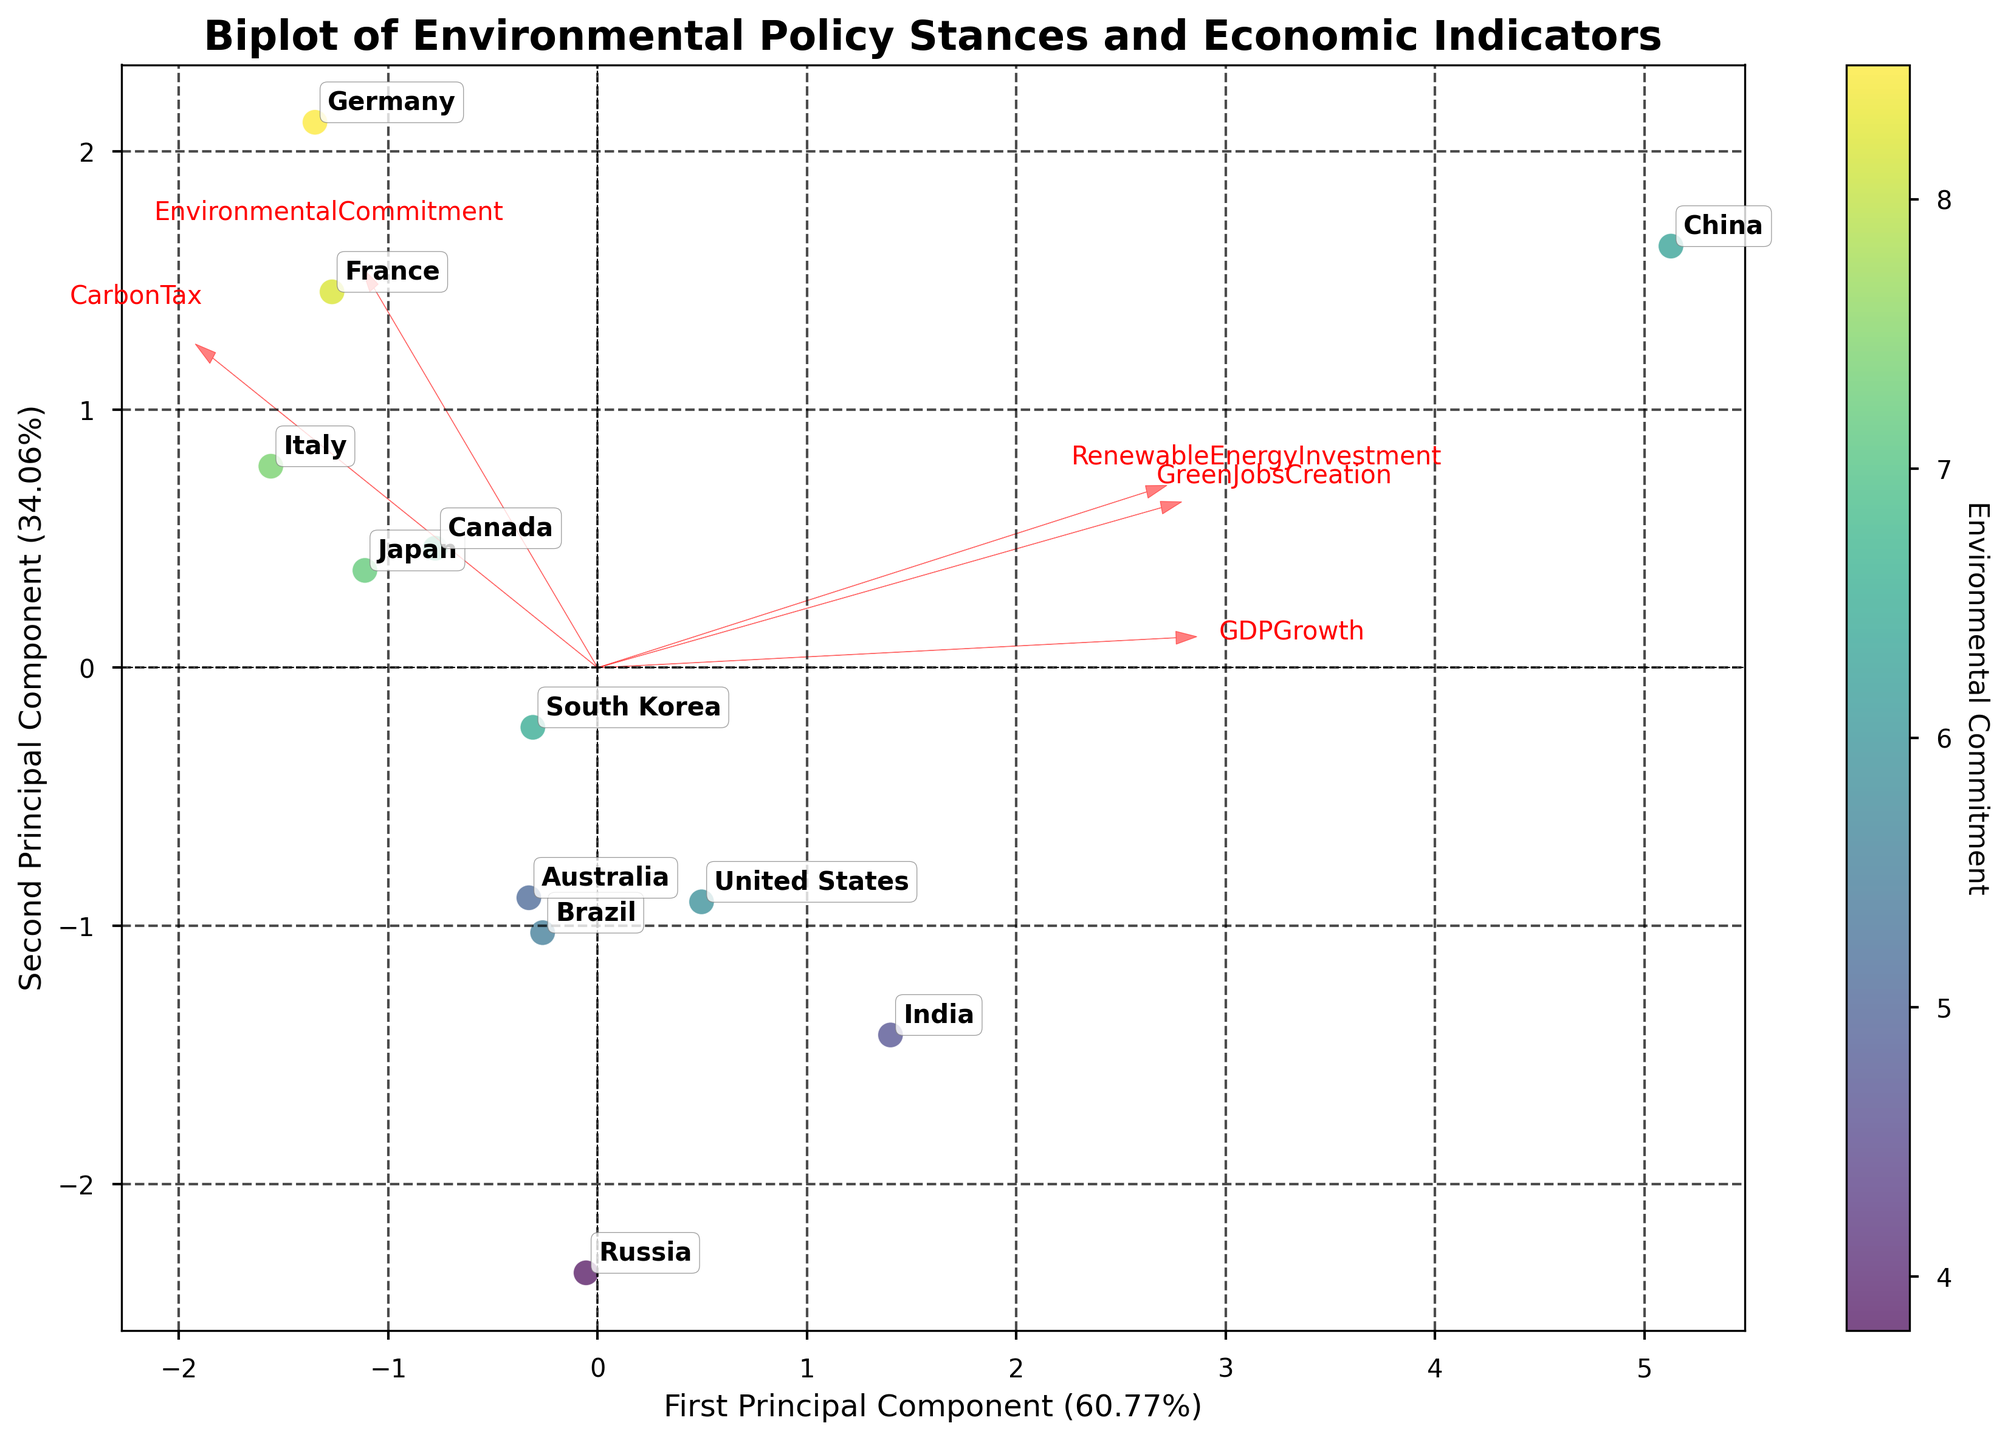What is the title of the figure? The title is typically found at the top of the figure, and it summarizes the main topic of the visualization.
Answer: Biplot of Environmental Policy Stances and Economic Indicators Which two principal components are represented on the axes? The labels on the x-axis and y-axis generally indicate the principal components.
Answer: First Principal Component and Second Principal Component Which country has the highest Environmental Commitment according to the color bar? The color bar depicts Environmental Commitment levels. The country with the darkest color has the highest commitment.
Answer: Germany Which variable has the largest vector in the biplot? The length of the vectors from the origin to their end points represents the magnitude of each variable.
Answer: CarbonTax Which two countries are closest to each other on the biplot? By visually inspecting the scatter plot points, you can find the countries with the smallest distance between their labels.
Answer: Japan and Italy What does the color of each point represent? The color bar usually indicates what the color represents in a plot.
Answer: Environmental Commitment Which country lies furthest to the right on the first principal component? By locating the point furthest along the x-axis, we find the country lying furthest to the right.
Answer: China Between India and Brazil, which country has a higher GDP Growth? To answer this, locate both countries on the biplot and compare their positions along the vertical axis representing the second principal component.
Answer: India What feature contributes most to the first principal component? By examining the magnitude and direction of the vectors concerning the first principal component, you can determine which feature contributes most.
Answer: RenewableEnergyInvestment If you sum the number of green jobs in Germany and France, what is the total? Adding the GreenJobsCreation values of Germany and France, you get 450,000 + 400,000 = 850,000.
Answer: 850,000 